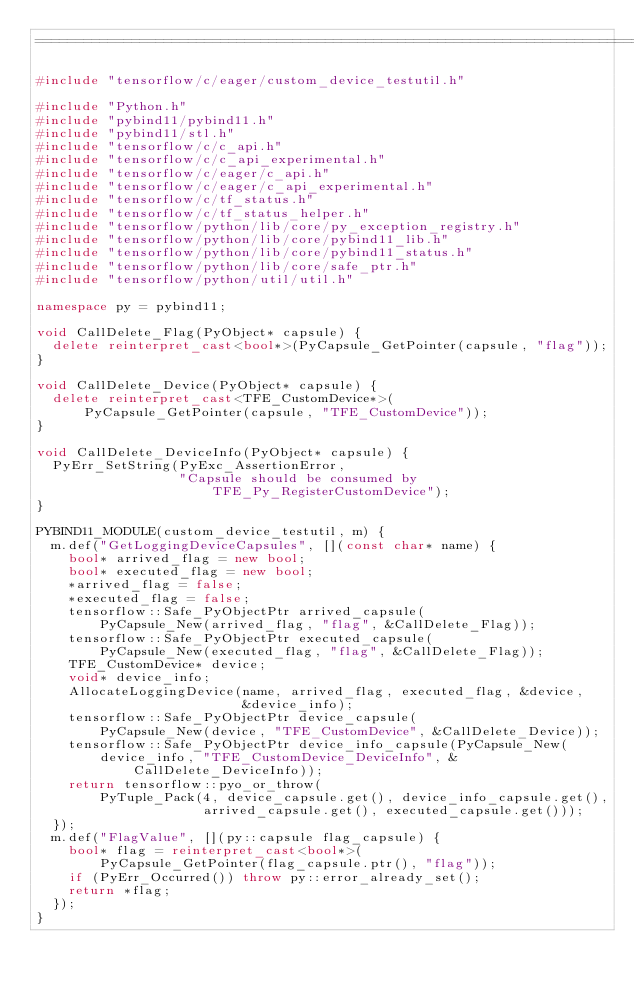<code> <loc_0><loc_0><loc_500><loc_500><_C++_>==============================================================================*/

#include "tensorflow/c/eager/custom_device_testutil.h"

#include "Python.h"
#include "pybind11/pybind11.h"
#include "pybind11/stl.h"
#include "tensorflow/c/c_api.h"
#include "tensorflow/c/c_api_experimental.h"
#include "tensorflow/c/eager/c_api.h"
#include "tensorflow/c/eager/c_api_experimental.h"
#include "tensorflow/c/tf_status.h"
#include "tensorflow/c/tf_status_helper.h"
#include "tensorflow/python/lib/core/py_exception_registry.h"
#include "tensorflow/python/lib/core/pybind11_lib.h"
#include "tensorflow/python/lib/core/pybind11_status.h"
#include "tensorflow/python/lib/core/safe_ptr.h"
#include "tensorflow/python/util/util.h"

namespace py = pybind11;

void CallDelete_Flag(PyObject* capsule) {
  delete reinterpret_cast<bool*>(PyCapsule_GetPointer(capsule, "flag"));
}

void CallDelete_Device(PyObject* capsule) {
  delete reinterpret_cast<TFE_CustomDevice*>(
      PyCapsule_GetPointer(capsule, "TFE_CustomDevice"));
}

void CallDelete_DeviceInfo(PyObject* capsule) {
  PyErr_SetString(PyExc_AssertionError,
                  "Capsule should be consumed by TFE_Py_RegisterCustomDevice");
}

PYBIND11_MODULE(custom_device_testutil, m) {
  m.def("GetLoggingDeviceCapsules", [](const char* name) {
    bool* arrived_flag = new bool;
    bool* executed_flag = new bool;
    *arrived_flag = false;
    *executed_flag = false;
    tensorflow::Safe_PyObjectPtr arrived_capsule(
        PyCapsule_New(arrived_flag, "flag", &CallDelete_Flag));
    tensorflow::Safe_PyObjectPtr executed_capsule(
        PyCapsule_New(executed_flag, "flag", &CallDelete_Flag));
    TFE_CustomDevice* device;
    void* device_info;
    AllocateLoggingDevice(name, arrived_flag, executed_flag, &device,
                          &device_info);
    tensorflow::Safe_PyObjectPtr device_capsule(
        PyCapsule_New(device, "TFE_CustomDevice", &CallDelete_Device));
    tensorflow::Safe_PyObjectPtr device_info_capsule(PyCapsule_New(
        device_info, "TFE_CustomDevice_DeviceInfo", &CallDelete_DeviceInfo));
    return tensorflow::pyo_or_throw(
        PyTuple_Pack(4, device_capsule.get(), device_info_capsule.get(),
                     arrived_capsule.get(), executed_capsule.get()));
  });
  m.def("FlagValue", [](py::capsule flag_capsule) {
    bool* flag = reinterpret_cast<bool*>(
        PyCapsule_GetPointer(flag_capsule.ptr(), "flag"));
    if (PyErr_Occurred()) throw py::error_already_set();
    return *flag;
  });
}
</code> 